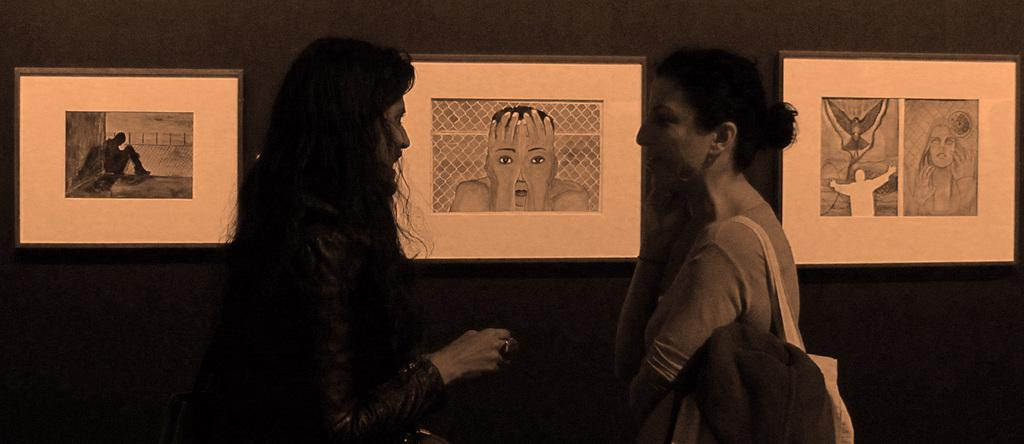What is the color scheme of the image? The image is black and white. How many people are in the image? There are two women standing in the image. What is one of the women wearing? One of the women is wearing a bag. What can be seen on the wall behind the women? There are drawings of people on the wall behind the women. Can you tell me how many deer are visible in the image? There are no deer present in the image; it features two women standing in a black and white setting with drawings of people on the wall behind them. 